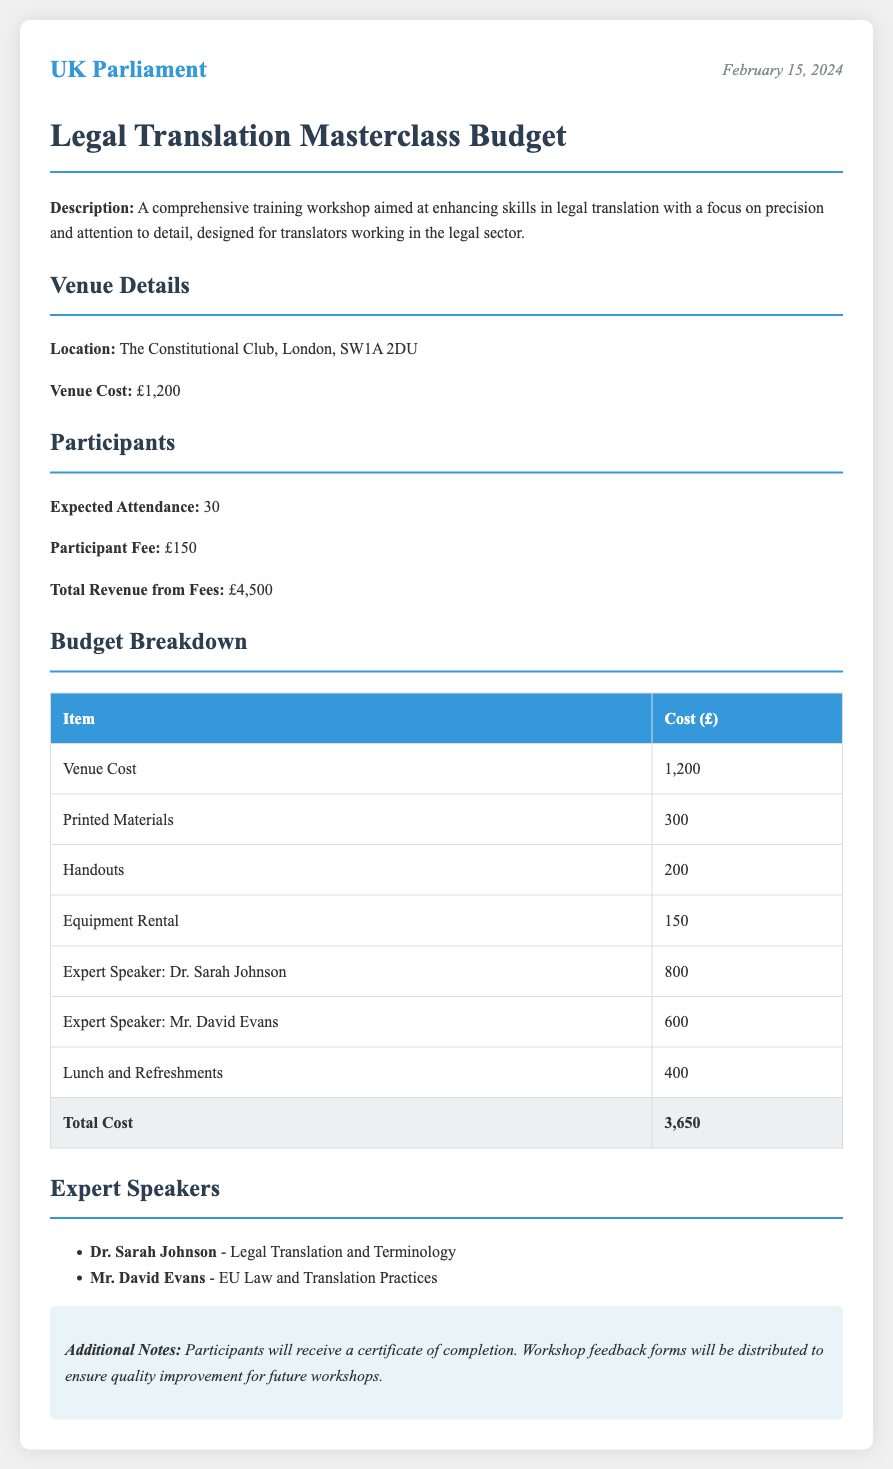What is the venue cost? The venue cost is explicitly stated under 'Venue Details' in the document.
Answer: £1,200 How many participants are expected? The expected attendance is listed in the 'Participants' section of the document.
Answer: 30 Who is the expert speaker for Legal Translation and Terminology? The document lists Dr. Sarah Johnson as the expert speaker for that subject.
Answer: Dr. Sarah Johnson What is the total cost of the training workshop? The total cost is identified in the 'Budget Breakdown' table at the end of the section.
Answer: £3,650 What is the participant fee? The participant fee is detailed in the 'Participants' section.
Answer: £150 How much is allocated for printed materials? The budget breakdown includes a specific allocation for printed materials as indicated in the table.
Answer: £300 What will participants receive upon completion of the workshop? The additional notes mention what participants will receive at the end of the training.
Answer: Certificate of completion Which venue is used for the workshop? The location of the workshop is provided in the 'Venue Details' section.
Answer: The Constitutional Club, London, SW1A 2DU Who is the second expert speaker listed? The 'Expert Speakers' section provides the names of both speakers, listing the second speaker.
Answer: Mr. David Evans 